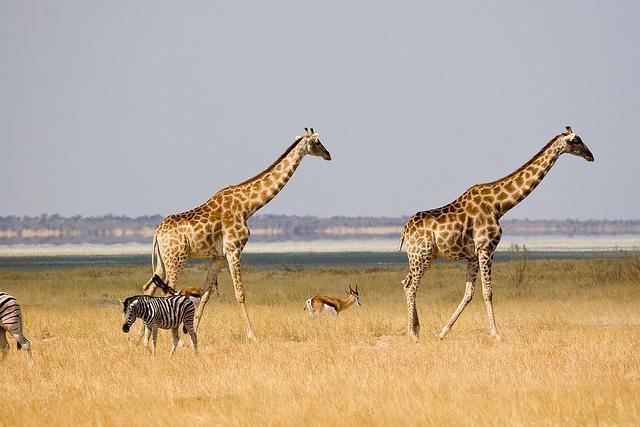How many giraffes are visible?
Give a very brief answer. 2. 